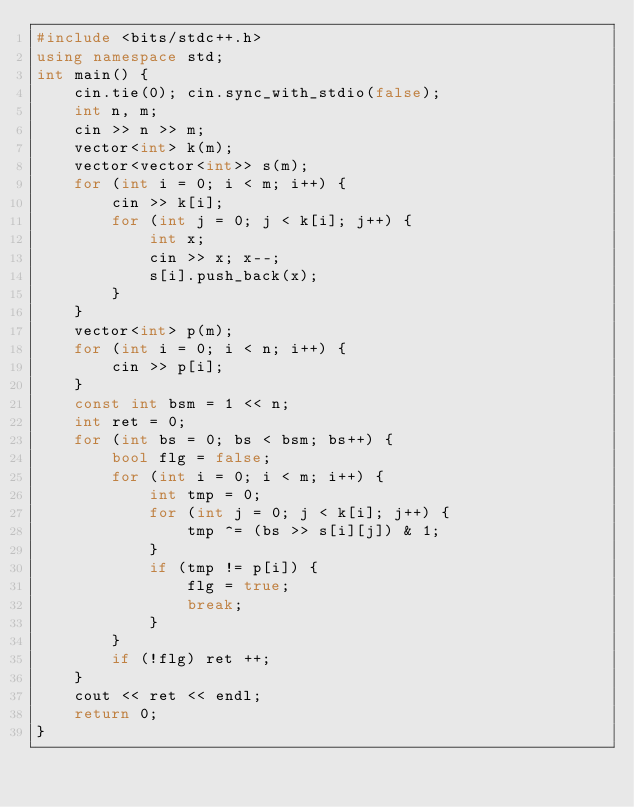Convert code to text. <code><loc_0><loc_0><loc_500><loc_500><_C++_>#include <bits/stdc++.h>
using namespace std;
int main() {
	cin.tie(0); cin.sync_with_stdio(false);
	int n, m;
	cin >> n >> m;
	vector<int> k(m);
	vector<vector<int>> s(m);
	for (int i = 0; i < m; i++) {
		cin >> k[i];
		for (int j = 0; j < k[i]; j++) {
			int x;
			cin >> x; x--;
			s[i].push_back(x);
		}
	}
	vector<int> p(m);
	for (int i = 0; i < n; i++) {
		cin >> p[i];
	}
	const int bsm = 1 << n;
	int ret = 0;
	for (int bs = 0; bs < bsm; bs++) {
		bool flg = false;
		for (int i = 0; i < m; i++) {
			int tmp = 0;
			for (int j = 0; j < k[i]; j++) {
				tmp ^= (bs >> s[i][j]) & 1;
			}
			if (tmp != p[i]) {
				flg = true;
				break;
			}
		}
		if (!flg) ret ++;
	}
	cout << ret << endl;
	return 0;
}</code> 